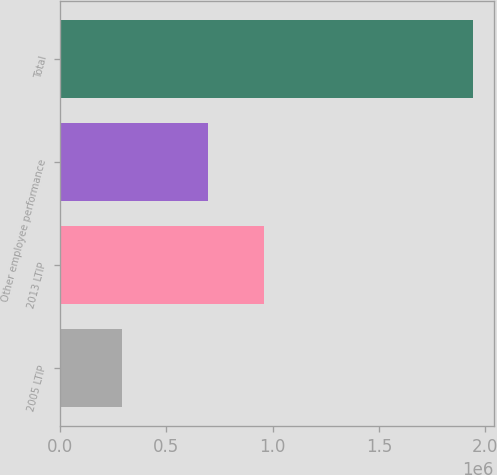Convert chart to OTSL. <chart><loc_0><loc_0><loc_500><loc_500><bar_chart><fcel>2005 LTIP<fcel>2013 LTIP<fcel>Other employee performance<fcel>Total<nl><fcel>288497<fcel>960000<fcel>695000<fcel>1.9435e+06<nl></chart> 